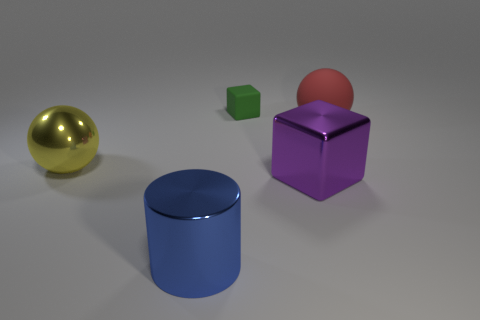Add 1 tiny green blocks. How many objects exist? 6 Subtract all cylinders. How many objects are left? 4 Add 4 large red matte objects. How many large red matte objects are left? 5 Add 4 yellow shiny objects. How many yellow shiny objects exist? 5 Subtract 0 blue balls. How many objects are left? 5 Subtract all small yellow matte balls. Subtract all big matte balls. How many objects are left? 4 